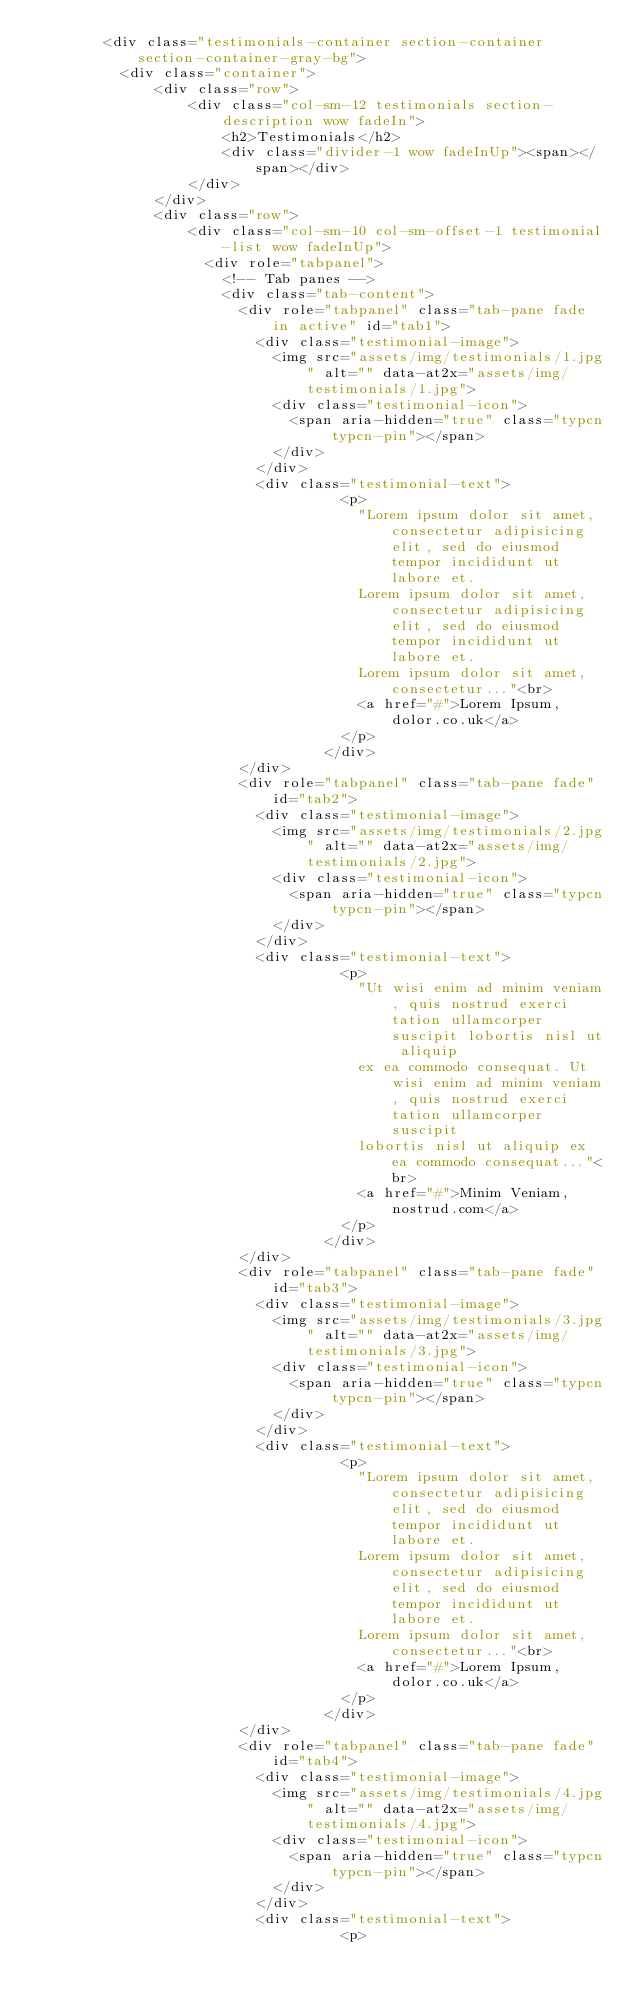Convert code to text. <code><loc_0><loc_0><loc_500><loc_500><_PHP_>        <div class="testimonials-container section-container section-container-gray-bg">
	        <div class="container">
	            <div class="row">
	                <div class="col-sm-12 testimonials section-description wow fadeIn">
	                    <h2>Testimonials</h2>
	                    <div class="divider-1 wow fadeInUp"><span></span></div>
	                </div>
	            </div>
	            <div class="row">
	                <div class="col-sm-10 col-sm-offset-1 testimonial-list wow fadeInUp">
	                	<div role="tabpanel">
	                		<!-- Tab panes -->
	                		<div class="tab-content">
	                			<div role="tabpanel" class="tab-pane fade in active" id="tab1">
	                				<div class="testimonial-image">
	                					<img src="assets/img/testimonials/1.jpg" alt="" data-at2x="assets/img/testimonials/1.jpg">
	                					<div class="testimonial-icon">
	                						<span aria-hidden="true" class="typcn typcn-pin"></span>
	                					</div>
	                				</div>
	                				<div class="testimonial-text">
		                                <p>
		                                	"Lorem ipsum dolor sit amet, consectetur adipisicing elit, sed do eiusmod tempor incididunt ut labore et. 
		                                	Lorem ipsum dolor sit amet, consectetur adipisicing elit, sed do eiusmod tempor incididunt ut labore et. 
		                                	Lorem ipsum dolor sit amet, consectetur..."<br>
		                                	<a href="#">Lorem Ipsum, dolor.co.uk</a>
		                                </p>
	                                </div>
	                			</div>
	                			<div role="tabpanel" class="tab-pane fade" id="tab2">
	                				<div class="testimonial-image">
	                					<img src="assets/img/testimonials/2.jpg" alt="" data-at2x="assets/img/testimonials/2.jpg">
	                					<div class="testimonial-icon">
	                						<span aria-hidden="true" class="typcn typcn-pin"></span>
	                					</div>
	                				</div>
	                				<div class="testimonial-text">
		                                <p>
		                                	"Ut wisi enim ad minim veniam, quis nostrud exerci tation ullamcorper suscipit lobortis nisl ut aliquip 
		                                	ex ea commodo consequat. Ut wisi enim ad minim veniam, quis nostrud exerci tation ullamcorper suscipit 
		                                	lobortis nisl ut aliquip ex ea commodo consequat..."<br>
		                                	<a href="#">Minim Veniam, nostrud.com</a>
		                                </p>
	                                </div>
	                			</div>
	                			<div role="tabpanel" class="tab-pane fade" id="tab3">
	                				<div class="testimonial-image">
	                					<img src="assets/img/testimonials/3.jpg" alt="" data-at2x="assets/img/testimonials/3.jpg">
	                					<div class="testimonial-icon">
	                						<span aria-hidden="true" class="typcn typcn-pin"></span>
	                					</div>
	                				</div>
	                				<div class="testimonial-text">
		                                <p>
		                                	"Lorem ipsum dolor sit amet, consectetur adipisicing elit, sed do eiusmod tempor incididunt ut labore et. 
		                                	Lorem ipsum dolor sit amet, consectetur adipisicing elit, sed do eiusmod tempor incididunt ut labore et. 
		                                	Lorem ipsum dolor sit amet, consectetur..."<br>
		                                	<a href="#">Lorem Ipsum, dolor.co.uk</a>
		                                </p>
	                                </div>
	                			</div>
	                			<div role="tabpanel" class="tab-pane fade" id="tab4">
	                				<div class="testimonial-image">
	                					<img src="assets/img/testimonials/4.jpg" alt="" data-at2x="assets/img/testimonials/4.jpg">
	                					<div class="testimonial-icon">
	                						<span aria-hidden="true" class="typcn typcn-pin"></span>
	                					</div>
	                				</div>
	                				<div class="testimonial-text">
		                                <p></code> 